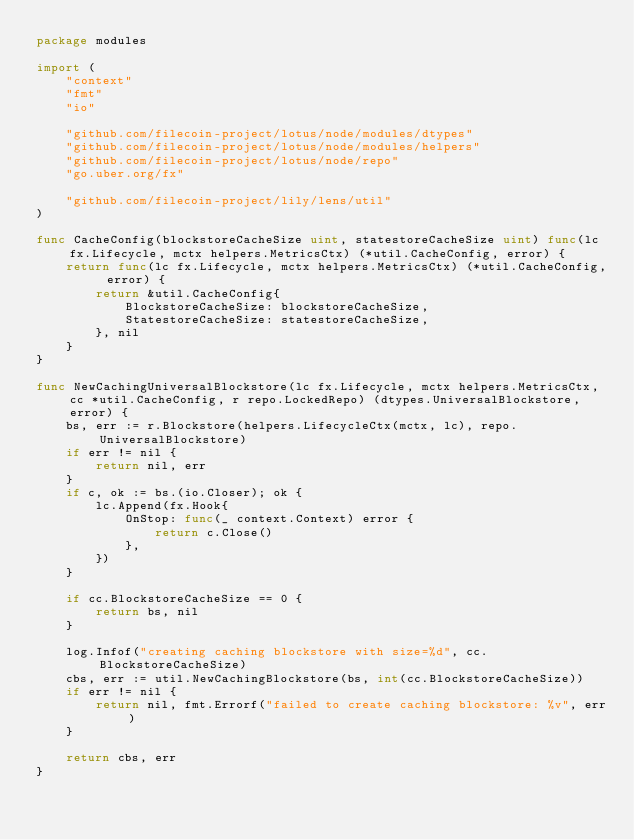Convert code to text. <code><loc_0><loc_0><loc_500><loc_500><_Go_>package modules

import (
	"context"
	"fmt"
	"io"

	"github.com/filecoin-project/lotus/node/modules/dtypes"
	"github.com/filecoin-project/lotus/node/modules/helpers"
	"github.com/filecoin-project/lotus/node/repo"
	"go.uber.org/fx"

	"github.com/filecoin-project/lily/lens/util"
)

func CacheConfig(blockstoreCacheSize uint, statestoreCacheSize uint) func(lc fx.Lifecycle, mctx helpers.MetricsCtx) (*util.CacheConfig, error) {
	return func(lc fx.Lifecycle, mctx helpers.MetricsCtx) (*util.CacheConfig, error) {
		return &util.CacheConfig{
			BlockstoreCacheSize: blockstoreCacheSize,
			StatestoreCacheSize: statestoreCacheSize,
		}, nil
	}
}

func NewCachingUniversalBlockstore(lc fx.Lifecycle, mctx helpers.MetricsCtx, cc *util.CacheConfig, r repo.LockedRepo) (dtypes.UniversalBlockstore, error) {
	bs, err := r.Blockstore(helpers.LifecycleCtx(mctx, lc), repo.UniversalBlockstore)
	if err != nil {
		return nil, err
	}
	if c, ok := bs.(io.Closer); ok {
		lc.Append(fx.Hook{
			OnStop: func(_ context.Context) error {
				return c.Close()
			},
		})
	}

	if cc.BlockstoreCacheSize == 0 {
		return bs, nil
	}

	log.Infof("creating caching blockstore with size=%d", cc.BlockstoreCacheSize)
	cbs, err := util.NewCachingBlockstore(bs, int(cc.BlockstoreCacheSize))
	if err != nil {
		return nil, fmt.Errorf("failed to create caching blockstore: %v", err)
	}

	return cbs, err
}
</code> 